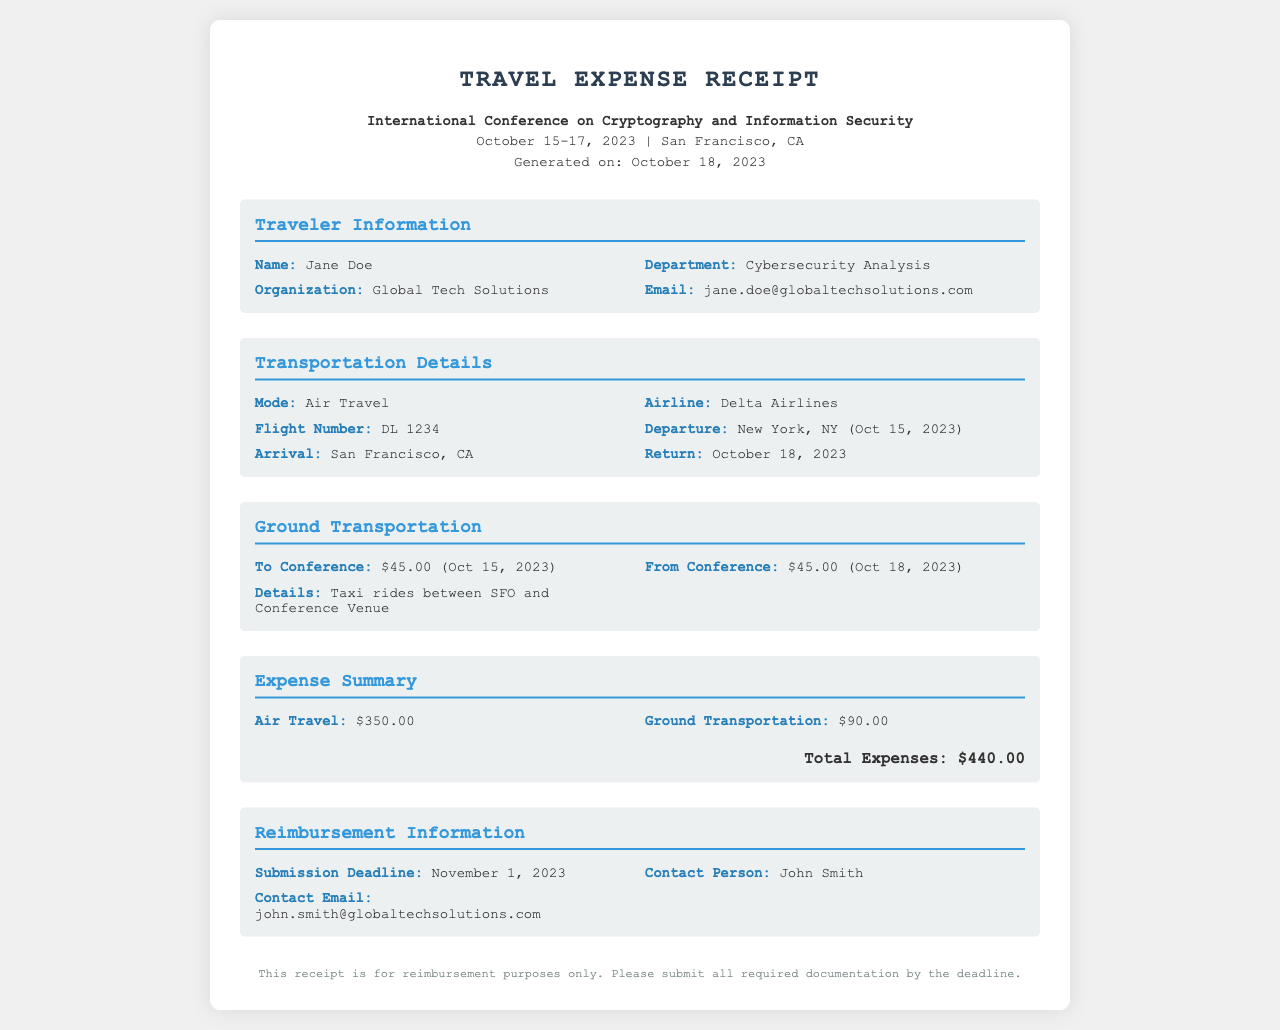What is the name of the traveler? The name of the traveler is mentioned in the document under Traveler Information.
Answer: Jane Doe What is the total amount for ground transportation? The ground transportation cost is described in the Expense Summary section of the document.
Answer: $90.00 What date does the conference take place? The conference dates are listed in the header section of the document.
Answer: October 15-17, 2023 What airline did the traveler use? The airline information is found in the Transportation Details section of the document.
Answer: Delta Airlines Who is the contact person for reimbursement? The contact person's name is stated in the Reimbursement Information section of the document.
Answer: John Smith What is the submission deadline for reimbursement? The deadline for submitting reimbursement requests is provided in the Reimbursement Information section.
Answer: November 1, 2023 What was the return date of the flight? The return date is specified in the Transportation Details section of the document.
Answer: October 18, 2023 What was the flight number? The flight number can be found in the Transportation Details section of the document.
Answer: DL 1234 What is the total expense amount? The total expenses are summarized in the Expense Summary section of the document.
Answer: $440.00 